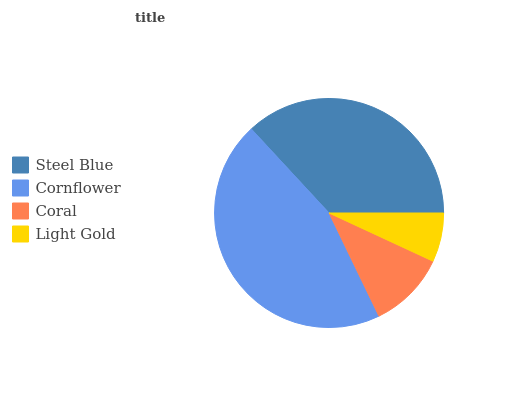Is Light Gold the minimum?
Answer yes or no. Yes. Is Cornflower the maximum?
Answer yes or no. Yes. Is Coral the minimum?
Answer yes or no. No. Is Coral the maximum?
Answer yes or no. No. Is Cornflower greater than Coral?
Answer yes or no. Yes. Is Coral less than Cornflower?
Answer yes or no. Yes. Is Coral greater than Cornflower?
Answer yes or no. No. Is Cornflower less than Coral?
Answer yes or no. No. Is Steel Blue the high median?
Answer yes or no. Yes. Is Coral the low median?
Answer yes or no. Yes. Is Coral the high median?
Answer yes or no. No. Is Light Gold the low median?
Answer yes or no. No. 